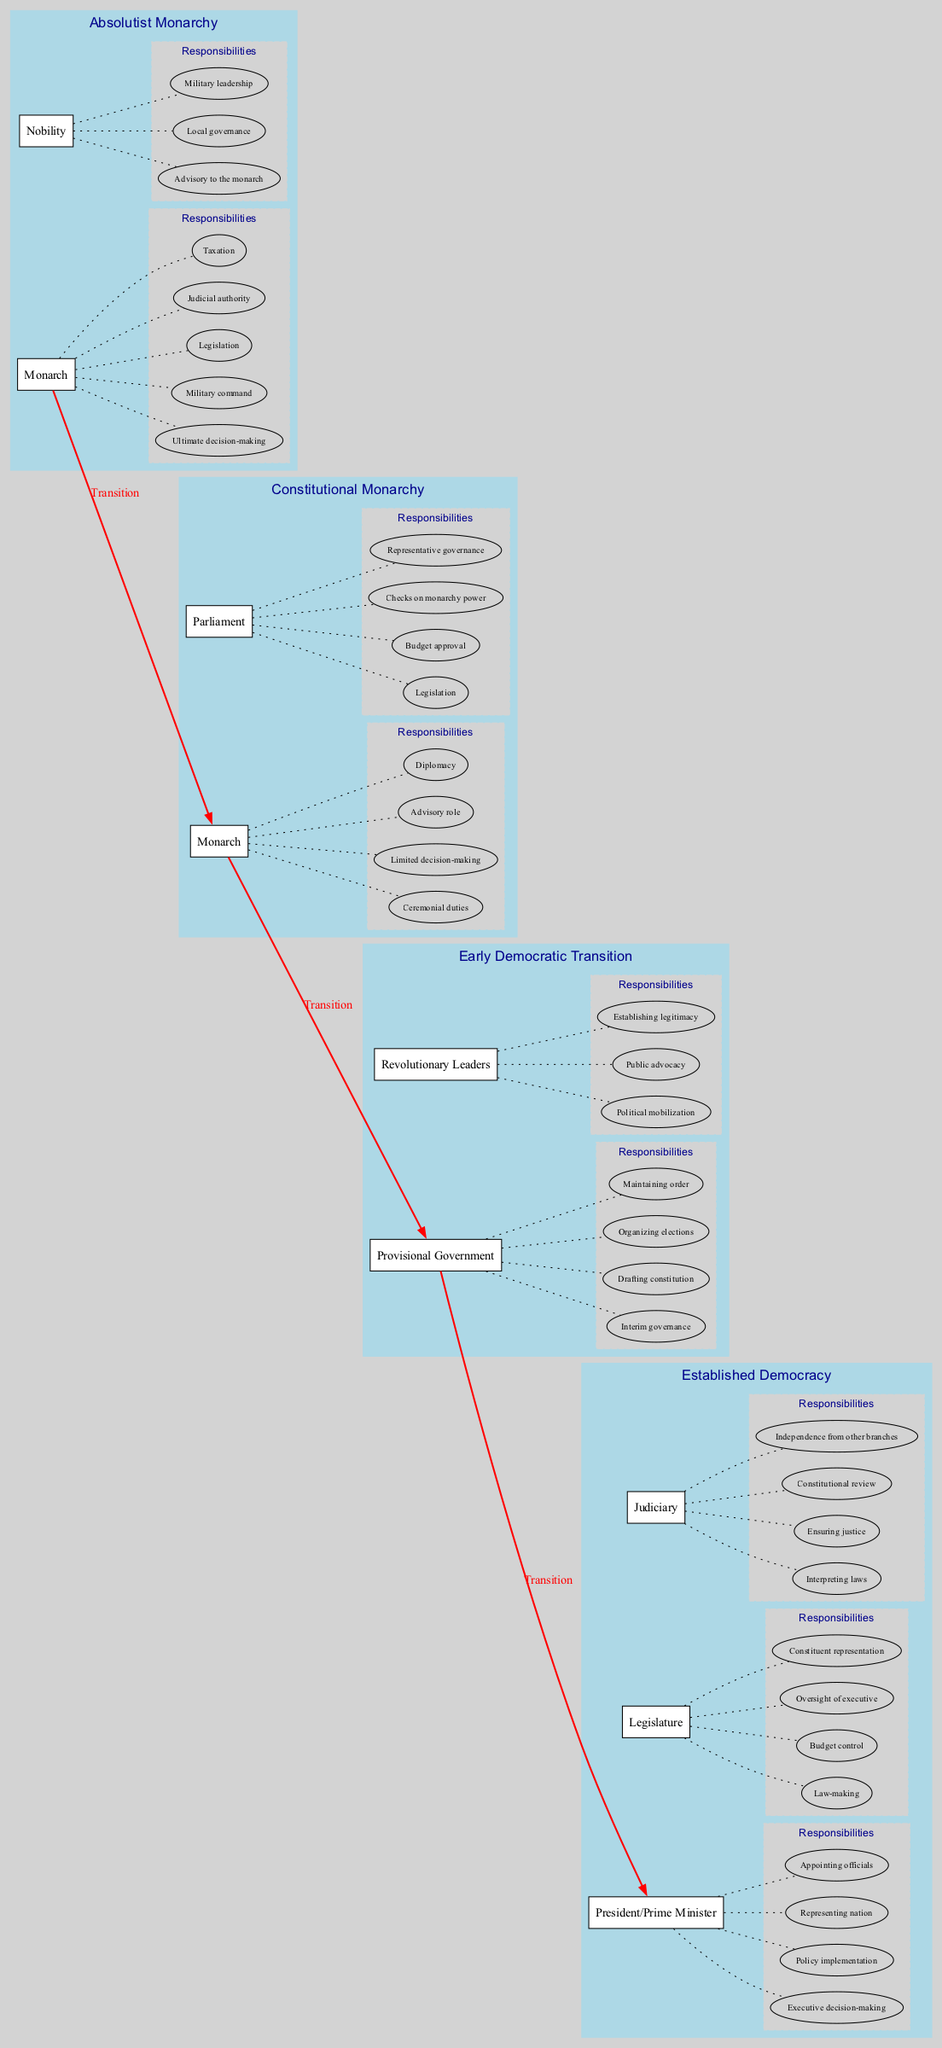What are the primary roles in the Absolutist Monarchy phase? The diagram lists two primary roles: Monarch and Nobility, indicating key figures in this phase of governance.
Answer: Monarch, Nobility How many responsibilities does the President/Prime Minister have in Established Democracy? In the diagram, the President/Prime Minister has four responsibilities listed under their role in the Established Democracy phase.
Answer: Four Which role assumes ceremonial duties in the Constitutional Monarchy phase? The diagram identifies the Monarch as the role responsible for ceremonial duties, marking a transition from complete power to a more symbolic function.
Answer: Monarch What is the key responsibility of the Legislature in Established Democracy? The diagram shows that law-making is a fundamental responsibility of the Legislature in the Established Democracy phase, signifying a crucial aspect of democratic governance.
Answer: Law-making What type of governance does the Provisional Government offer in the Early Democratic Transition phase? According to the diagram, the Provisional Government offers interim governance, indicating its temporary role during the transition towards a more stable governance structure.
Answer: Interim governance How many elements are shown in the Constitutional Monarchy phase? The diagram indicates that there are two elements in the Constitutional Monarchy phase: the Monarch and Parliament, representing a shift in roles.
Answer: Two What role checks the power of the monarchy in the Constitutional Monarchy phase? The diagram specifies that the Parliament has the responsibility to check the monarchy's power, illustrating a significant shift towards balanced governance.
Answer: Parliament How does the transition from Absolutist Monarchy to Constitutional Monarchy primarily occur? The diagram illustrates a red arrow labeled 'Transition' that connects the two phases, highlighting the sequence of governance change from total monarchy to a constitutional framework.
Answer: Transition What responsibilities are connected to the Judiciary in Established Democracy? The diagram lists four responsibilities for the Judiciary, focusing on interpreting laws, ensuring justice, conducting constitutional reviews, and maintaining independence from other branches.
Answer: Interpreting laws, ensuring justice, constitutional review, independence from other branches 